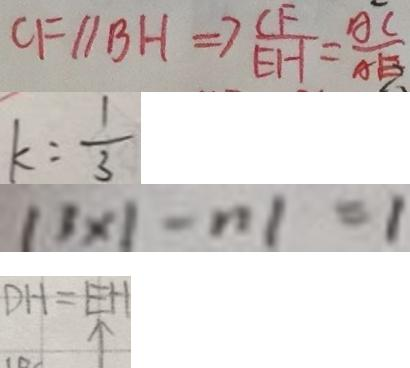Convert formula to latex. <formula><loc_0><loc_0><loc_500><loc_500>C F / / B H \Rightarrow \frac { C F } { E H } = \frac { A C } { A H } 
 k = \frac { 1 } { 3 } 
 1 3 \times \vert - n \vert = 1 
 D H = E H \uparrow</formula> 